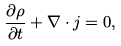Convert formula to latex. <formula><loc_0><loc_0><loc_500><loc_500>\frac { \partial \rho } { \partial t } + \nabla \cdot { j } = 0 ,</formula> 